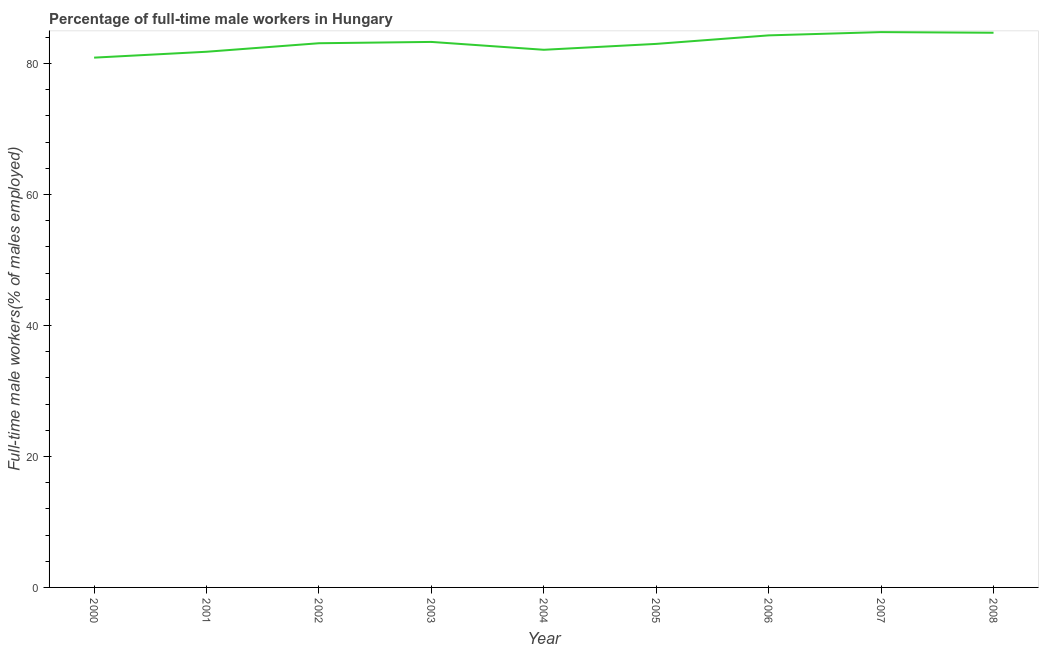What is the percentage of full-time male workers in 2006?
Your response must be concise. 84.3. Across all years, what is the maximum percentage of full-time male workers?
Keep it short and to the point. 84.8. Across all years, what is the minimum percentage of full-time male workers?
Give a very brief answer. 80.9. What is the sum of the percentage of full-time male workers?
Offer a terse response. 748. What is the difference between the percentage of full-time male workers in 2005 and 2008?
Your answer should be very brief. -1.7. What is the average percentage of full-time male workers per year?
Keep it short and to the point. 83.11. What is the median percentage of full-time male workers?
Your answer should be very brief. 83.1. Do a majority of the years between 2004 and 2007 (inclusive) have percentage of full-time male workers greater than 48 %?
Ensure brevity in your answer.  Yes. What is the ratio of the percentage of full-time male workers in 2005 to that in 2007?
Your answer should be compact. 0.98. Is the difference between the percentage of full-time male workers in 2002 and 2007 greater than the difference between any two years?
Keep it short and to the point. No. What is the difference between the highest and the second highest percentage of full-time male workers?
Make the answer very short. 0.1. What is the difference between the highest and the lowest percentage of full-time male workers?
Keep it short and to the point. 3.9. How many lines are there?
Provide a short and direct response. 1. Are the values on the major ticks of Y-axis written in scientific E-notation?
Your answer should be very brief. No. Does the graph contain any zero values?
Offer a terse response. No. What is the title of the graph?
Offer a very short reply. Percentage of full-time male workers in Hungary. What is the label or title of the X-axis?
Your answer should be very brief. Year. What is the label or title of the Y-axis?
Ensure brevity in your answer.  Full-time male workers(% of males employed). What is the Full-time male workers(% of males employed) of 2000?
Keep it short and to the point. 80.9. What is the Full-time male workers(% of males employed) of 2001?
Provide a succinct answer. 81.8. What is the Full-time male workers(% of males employed) in 2002?
Your response must be concise. 83.1. What is the Full-time male workers(% of males employed) in 2003?
Your answer should be compact. 83.3. What is the Full-time male workers(% of males employed) in 2004?
Make the answer very short. 82.1. What is the Full-time male workers(% of males employed) of 2005?
Offer a very short reply. 83. What is the Full-time male workers(% of males employed) in 2006?
Give a very brief answer. 84.3. What is the Full-time male workers(% of males employed) in 2007?
Make the answer very short. 84.8. What is the Full-time male workers(% of males employed) of 2008?
Provide a succinct answer. 84.7. What is the difference between the Full-time male workers(% of males employed) in 2000 and 2002?
Provide a succinct answer. -2.2. What is the difference between the Full-time male workers(% of males employed) in 2000 and 2005?
Provide a short and direct response. -2.1. What is the difference between the Full-time male workers(% of males employed) in 2001 and 2003?
Keep it short and to the point. -1.5. What is the difference between the Full-time male workers(% of males employed) in 2001 and 2004?
Offer a terse response. -0.3. What is the difference between the Full-time male workers(% of males employed) in 2001 and 2008?
Offer a very short reply. -2.9. What is the difference between the Full-time male workers(% of males employed) in 2002 and 2005?
Your answer should be very brief. 0.1. What is the difference between the Full-time male workers(% of males employed) in 2002 and 2006?
Provide a short and direct response. -1.2. What is the difference between the Full-time male workers(% of males employed) in 2002 and 2007?
Your answer should be very brief. -1.7. What is the difference between the Full-time male workers(% of males employed) in 2003 and 2004?
Ensure brevity in your answer.  1.2. What is the difference between the Full-time male workers(% of males employed) in 2003 and 2006?
Provide a short and direct response. -1. What is the difference between the Full-time male workers(% of males employed) in 2003 and 2007?
Give a very brief answer. -1.5. What is the difference between the Full-time male workers(% of males employed) in 2003 and 2008?
Offer a terse response. -1.4. What is the difference between the Full-time male workers(% of males employed) in 2004 and 2006?
Offer a very short reply. -2.2. What is the difference between the Full-time male workers(% of males employed) in 2004 and 2007?
Give a very brief answer. -2.7. What is the difference between the Full-time male workers(% of males employed) in 2005 and 2007?
Your response must be concise. -1.8. What is the difference between the Full-time male workers(% of males employed) in 2006 and 2008?
Your answer should be very brief. -0.4. What is the difference between the Full-time male workers(% of males employed) in 2007 and 2008?
Ensure brevity in your answer.  0.1. What is the ratio of the Full-time male workers(% of males employed) in 2000 to that in 2001?
Your response must be concise. 0.99. What is the ratio of the Full-time male workers(% of males employed) in 2000 to that in 2007?
Offer a very short reply. 0.95. What is the ratio of the Full-time male workers(% of males employed) in 2000 to that in 2008?
Give a very brief answer. 0.95. What is the ratio of the Full-time male workers(% of males employed) in 2001 to that in 2003?
Give a very brief answer. 0.98. What is the ratio of the Full-time male workers(% of males employed) in 2001 to that in 2004?
Ensure brevity in your answer.  1. What is the ratio of the Full-time male workers(% of males employed) in 2002 to that in 2003?
Provide a succinct answer. 1. What is the ratio of the Full-time male workers(% of males employed) in 2002 to that in 2006?
Make the answer very short. 0.99. What is the ratio of the Full-time male workers(% of males employed) in 2003 to that in 2008?
Provide a short and direct response. 0.98. What is the ratio of the Full-time male workers(% of males employed) in 2004 to that in 2006?
Provide a short and direct response. 0.97. What is the ratio of the Full-time male workers(% of males employed) in 2004 to that in 2007?
Offer a terse response. 0.97. What is the ratio of the Full-time male workers(% of males employed) in 2005 to that in 2006?
Make the answer very short. 0.98. What is the ratio of the Full-time male workers(% of males employed) in 2005 to that in 2007?
Ensure brevity in your answer.  0.98. What is the ratio of the Full-time male workers(% of males employed) in 2007 to that in 2008?
Keep it short and to the point. 1. 